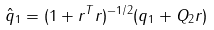Convert formula to latex. <formula><loc_0><loc_0><loc_500><loc_500>\hat { q } _ { 1 } = ( 1 + r ^ { T } r ) ^ { - 1 / 2 } ( q _ { 1 } + Q _ { 2 } r )</formula> 